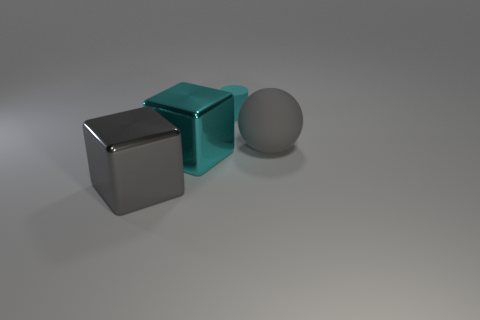Add 4 big blue rubber objects. How many objects exist? 8 Subtract all gray cubes. How many cubes are left? 1 Subtract all cylinders. How many objects are left? 3 Add 1 tiny cyan rubber balls. How many tiny cyan rubber balls exist? 1 Subtract 0 green cylinders. How many objects are left? 4 Subtract all purple balls. Subtract all yellow cylinders. How many balls are left? 1 Subtract all cubes. Subtract all matte cylinders. How many objects are left? 1 Add 3 cyan metal objects. How many cyan metal objects are left? 4 